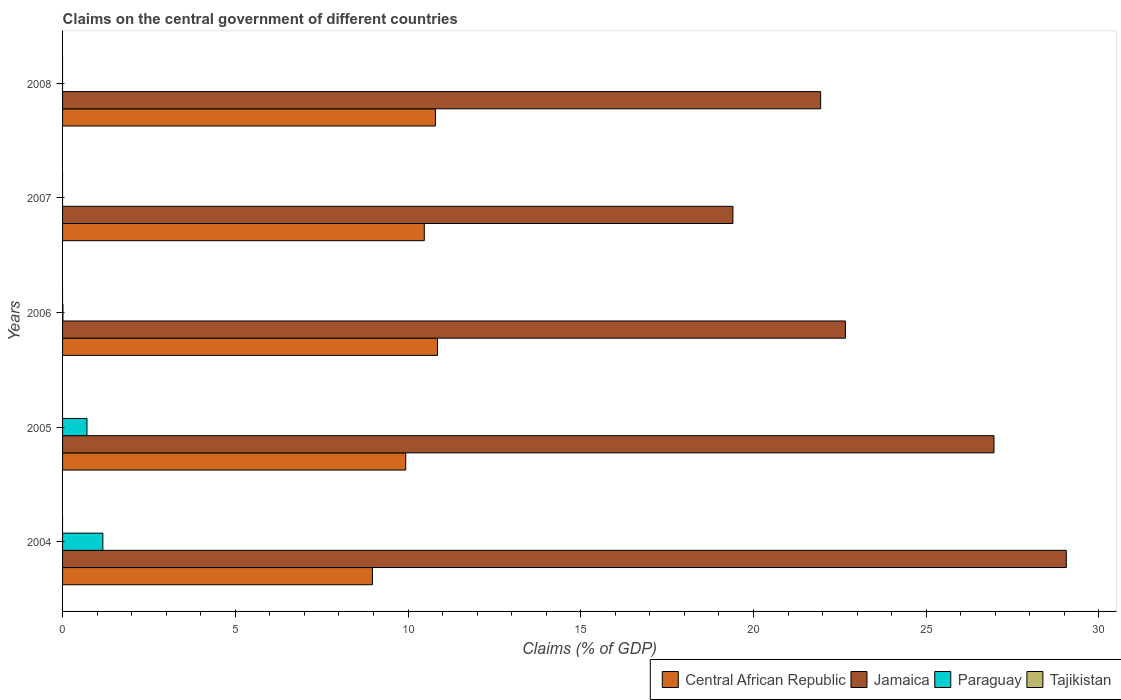How many groups of bars are there?
Your answer should be compact. 5. How many bars are there on the 5th tick from the top?
Your response must be concise. 3. How many bars are there on the 2nd tick from the bottom?
Offer a terse response. 3. What is the label of the 5th group of bars from the top?
Give a very brief answer. 2004. In how many cases, is the number of bars for a given year not equal to the number of legend labels?
Provide a short and direct response. 5. What is the percentage of GDP claimed on the central government in Tajikistan in 2008?
Offer a very short reply. 0. Across all years, what is the maximum percentage of GDP claimed on the central government in Jamaica?
Offer a very short reply. 29.06. Across all years, what is the minimum percentage of GDP claimed on the central government in Tajikistan?
Your response must be concise. 0. In which year was the percentage of GDP claimed on the central government in Central African Republic maximum?
Give a very brief answer. 2006. What is the total percentage of GDP claimed on the central government in Paraguay in the graph?
Your response must be concise. 1.88. What is the difference between the percentage of GDP claimed on the central government in Jamaica in 2004 and that in 2008?
Your answer should be very brief. 7.11. What is the difference between the percentage of GDP claimed on the central government in Tajikistan in 2004 and the percentage of GDP claimed on the central government in Central African Republic in 2005?
Your answer should be very brief. -9.93. In the year 2004, what is the difference between the percentage of GDP claimed on the central government in Paraguay and percentage of GDP claimed on the central government in Central African Republic?
Your answer should be very brief. -7.8. What is the ratio of the percentage of GDP claimed on the central government in Central African Republic in 2006 to that in 2007?
Offer a very short reply. 1.04. Is the percentage of GDP claimed on the central government in Central African Republic in 2004 less than that in 2008?
Ensure brevity in your answer.  Yes. What is the difference between the highest and the second highest percentage of GDP claimed on the central government in Paraguay?
Offer a terse response. 0.46. What is the difference between the highest and the lowest percentage of GDP claimed on the central government in Jamaica?
Provide a short and direct response. 9.65. In how many years, is the percentage of GDP claimed on the central government in Tajikistan greater than the average percentage of GDP claimed on the central government in Tajikistan taken over all years?
Offer a terse response. 0. Is the sum of the percentage of GDP claimed on the central government in Jamaica in 2005 and 2008 greater than the maximum percentage of GDP claimed on the central government in Paraguay across all years?
Your answer should be compact. Yes. Is it the case that in every year, the sum of the percentage of GDP claimed on the central government in Tajikistan and percentage of GDP claimed on the central government in Jamaica is greater than the sum of percentage of GDP claimed on the central government in Central African Republic and percentage of GDP claimed on the central government in Paraguay?
Your answer should be compact. Yes. Is it the case that in every year, the sum of the percentage of GDP claimed on the central government in Paraguay and percentage of GDP claimed on the central government in Central African Republic is greater than the percentage of GDP claimed on the central government in Tajikistan?
Make the answer very short. Yes. Are all the bars in the graph horizontal?
Ensure brevity in your answer.  Yes. Does the graph contain grids?
Ensure brevity in your answer.  No. How many legend labels are there?
Offer a terse response. 4. How are the legend labels stacked?
Offer a terse response. Horizontal. What is the title of the graph?
Offer a terse response. Claims on the central government of different countries. What is the label or title of the X-axis?
Keep it short and to the point. Claims (% of GDP). What is the Claims (% of GDP) in Central African Republic in 2004?
Ensure brevity in your answer.  8.97. What is the Claims (% of GDP) in Jamaica in 2004?
Make the answer very short. 29.06. What is the Claims (% of GDP) in Paraguay in 2004?
Keep it short and to the point. 1.17. What is the Claims (% of GDP) of Tajikistan in 2004?
Your answer should be compact. 0. What is the Claims (% of GDP) of Central African Republic in 2005?
Offer a terse response. 9.93. What is the Claims (% of GDP) of Jamaica in 2005?
Offer a very short reply. 26.96. What is the Claims (% of GDP) in Paraguay in 2005?
Your response must be concise. 0.71. What is the Claims (% of GDP) in Tajikistan in 2005?
Provide a succinct answer. 0. What is the Claims (% of GDP) of Central African Republic in 2006?
Provide a succinct answer. 10.85. What is the Claims (% of GDP) in Jamaica in 2006?
Offer a terse response. 22.66. What is the Claims (% of GDP) of Paraguay in 2006?
Ensure brevity in your answer.  0.01. What is the Claims (% of GDP) of Central African Republic in 2007?
Give a very brief answer. 10.47. What is the Claims (% of GDP) of Jamaica in 2007?
Offer a terse response. 19.41. What is the Claims (% of GDP) of Paraguay in 2007?
Your response must be concise. 0. What is the Claims (% of GDP) in Tajikistan in 2007?
Provide a succinct answer. 0. What is the Claims (% of GDP) in Central African Republic in 2008?
Give a very brief answer. 10.79. What is the Claims (% of GDP) of Jamaica in 2008?
Give a very brief answer. 21.94. What is the Claims (% of GDP) of Paraguay in 2008?
Make the answer very short. 0. Across all years, what is the maximum Claims (% of GDP) of Central African Republic?
Keep it short and to the point. 10.85. Across all years, what is the maximum Claims (% of GDP) of Jamaica?
Offer a very short reply. 29.06. Across all years, what is the maximum Claims (% of GDP) in Paraguay?
Give a very brief answer. 1.17. Across all years, what is the minimum Claims (% of GDP) in Central African Republic?
Offer a very short reply. 8.97. Across all years, what is the minimum Claims (% of GDP) of Jamaica?
Provide a succinct answer. 19.41. What is the total Claims (% of GDP) of Central African Republic in the graph?
Make the answer very short. 51.02. What is the total Claims (% of GDP) in Jamaica in the graph?
Ensure brevity in your answer.  120.03. What is the total Claims (% of GDP) in Paraguay in the graph?
Make the answer very short. 1.88. What is the difference between the Claims (% of GDP) in Central African Republic in 2004 and that in 2005?
Your answer should be very brief. -0.96. What is the difference between the Claims (% of GDP) in Jamaica in 2004 and that in 2005?
Your response must be concise. 2.09. What is the difference between the Claims (% of GDP) in Paraguay in 2004 and that in 2005?
Provide a succinct answer. 0.46. What is the difference between the Claims (% of GDP) in Central African Republic in 2004 and that in 2006?
Your answer should be very brief. -1.88. What is the difference between the Claims (% of GDP) of Jamaica in 2004 and that in 2006?
Offer a terse response. 6.4. What is the difference between the Claims (% of GDP) of Paraguay in 2004 and that in 2006?
Your response must be concise. 1.16. What is the difference between the Claims (% of GDP) in Central African Republic in 2004 and that in 2007?
Make the answer very short. -1.5. What is the difference between the Claims (% of GDP) of Jamaica in 2004 and that in 2007?
Offer a terse response. 9.65. What is the difference between the Claims (% of GDP) in Central African Republic in 2004 and that in 2008?
Your response must be concise. -1.82. What is the difference between the Claims (% of GDP) in Jamaica in 2004 and that in 2008?
Your response must be concise. 7.11. What is the difference between the Claims (% of GDP) of Central African Republic in 2005 and that in 2006?
Your response must be concise. -0.92. What is the difference between the Claims (% of GDP) in Jamaica in 2005 and that in 2006?
Keep it short and to the point. 4.3. What is the difference between the Claims (% of GDP) of Paraguay in 2005 and that in 2006?
Offer a terse response. 0.7. What is the difference between the Claims (% of GDP) in Central African Republic in 2005 and that in 2007?
Your answer should be compact. -0.54. What is the difference between the Claims (% of GDP) in Jamaica in 2005 and that in 2007?
Your answer should be very brief. 7.56. What is the difference between the Claims (% of GDP) in Central African Republic in 2005 and that in 2008?
Keep it short and to the point. -0.86. What is the difference between the Claims (% of GDP) in Jamaica in 2005 and that in 2008?
Make the answer very short. 5.02. What is the difference between the Claims (% of GDP) of Central African Republic in 2006 and that in 2007?
Make the answer very short. 0.38. What is the difference between the Claims (% of GDP) of Jamaica in 2006 and that in 2007?
Give a very brief answer. 3.26. What is the difference between the Claims (% of GDP) of Central African Republic in 2006 and that in 2008?
Make the answer very short. 0.06. What is the difference between the Claims (% of GDP) in Jamaica in 2006 and that in 2008?
Give a very brief answer. 0.72. What is the difference between the Claims (% of GDP) of Central African Republic in 2007 and that in 2008?
Provide a short and direct response. -0.32. What is the difference between the Claims (% of GDP) of Jamaica in 2007 and that in 2008?
Provide a succinct answer. -2.54. What is the difference between the Claims (% of GDP) of Central African Republic in 2004 and the Claims (% of GDP) of Jamaica in 2005?
Give a very brief answer. -17.99. What is the difference between the Claims (% of GDP) in Central African Republic in 2004 and the Claims (% of GDP) in Paraguay in 2005?
Offer a very short reply. 8.26. What is the difference between the Claims (% of GDP) in Jamaica in 2004 and the Claims (% of GDP) in Paraguay in 2005?
Offer a terse response. 28.35. What is the difference between the Claims (% of GDP) in Central African Republic in 2004 and the Claims (% of GDP) in Jamaica in 2006?
Make the answer very short. -13.69. What is the difference between the Claims (% of GDP) in Central African Republic in 2004 and the Claims (% of GDP) in Paraguay in 2006?
Offer a very short reply. 8.96. What is the difference between the Claims (% of GDP) in Jamaica in 2004 and the Claims (% of GDP) in Paraguay in 2006?
Keep it short and to the point. 29.05. What is the difference between the Claims (% of GDP) in Central African Republic in 2004 and the Claims (% of GDP) in Jamaica in 2007?
Ensure brevity in your answer.  -10.43. What is the difference between the Claims (% of GDP) in Central African Republic in 2004 and the Claims (% of GDP) in Jamaica in 2008?
Make the answer very short. -12.97. What is the difference between the Claims (% of GDP) in Central African Republic in 2005 and the Claims (% of GDP) in Jamaica in 2006?
Your answer should be compact. -12.73. What is the difference between the Claims (% of GDP) in Central African Republic in 2005 and the Claims (% of GDP) in Paraguay in 2006?
Your response must be concise. 9.92. What is the difference between the Claims (% of GDP) of Jamaica in 2005 and the Claims (% of GDP) of Paraguay in 2006?
Offer a very short reply. 26.95. What is the difference between the Claims (% of GDP) of Central African Republic in 2005 and the Claims (% of GDP) of Jamaica in 2007?
Your answer should be compact. -9.47. What is the difference between the Claims (% of GDP) in Central African Republic in 2005 and the Claims (% of GDP) in Jamaica in 2008?
Your answer should be compact. -12.01. What is the difference between the Claims (% of GDP) in Central African Republic in 2006 and the Claims (% of GDP) in Jamaica in 2007?
Give a very brief answer. -8.55. What is the difference between the Claims (% of GDP) in Central African Republic in 2006 and the Claims (% of GDP) in Jamaica in 2008?
Your answer should be compact. -11.09. What is the difference between the Claims (% of GDP) in Central African Republic in 2007 and the Claims (% of GDP) in Jamaica in 2008?
Give a very brief answer. -11.47. What is the average Claims (% of GDP) of Central African Republic per year?
Ensure brevity in your answer.  10.2. What is the average Claims (% of GDP) in Jamaica per year?
Offer a very short reply. 24.01. What is the average Claims (% of GDP) of Paraguay per year?
Make the answer very short. 0.38. In the year 2004, what is the difference between the Claims (% of GDP) in Central African Republic and Claims (% of GDP) in Jamaica?
Offer a very short reply. -20.09. In the year 2004, what is the difference between the Claims (% of GDP) of Central African Republic and Claims (% of GDP) of Paraguay?
Provide a succinct answer. 7.8. In the year 2004, what is the difference between the Claims (% of GDP) of Jamaica and Claims (% of GDP) of Paraguay?
Your answer should be compact. 27.89. In the year 2005, what is the difference between the Claims (% of GDP) of Central African Republic and Claims (% of GDP) of Jamaica?
Keep it short and to the point. -17.03. In the year 2005, what is the difference between the Claims (% of GDP) of Central African Republic and Claims (% of GDP) of Paraguay?
Ensure brevity in your answer.  9.23. In the year 2005, what is the difference between the Claims (% of GDP) in Jamaica and Claims (% of GDP) in Paraguay?
Ensure brevity in your answer.  26.26. In the year 2006, what is the difference between the Claims (% of GDP) in Central African Republic and Claims (% of GDP) in Jamaica?
Offer a terse response. -11.81. In the year 2006, what is the difference between the Claims (% of GDP) of Central African Republic and Claims (% of GDP) of Paraguay?
Give a very brief answer. 10.84. In the year 2006, what is the difference between the Claims (% of GDP) in Jamaica and Claims (% of GDP) in Paraguay?
Give a very brief answer. 22.65. In the year 2007, what is the difference between the Claims (% of GDP) of Central African Republic and Claims (% of GDP) of Jamaica?
Offer a very short reply. -8.93. In the year 2008, what is the difference between the Claims (% of GDP) in Central African Republic and Claims (% of GDP) in Jamaica?
Make the answer very short. -11.15. What is the ratio of the Claims (% of GDP) in Central African Republic in 2004 to that in 2005?
Your answer should be compact. 0.9. What is the ratio of the Claims (% of GDP) of Jamaica in 2004 to that in 2005?
Provide a succinct answer. 1.08. What is the ratio of the Claims (% of GDP) of Paraguay in 2004 to that in 2005?
Keep it short and to the point. 1.65. What is the ratio of the Claims (% of GDP) of Central African Republic in 2004 to that in 2006?
Offer a very short reply. 0.83. What is the ratio of the Claims (% of GDP) in Jamaica in 2004 to that in 2006?
Keep it short and to the point. 1.28. What is the ratio of the Claims (% of GDP) of Paraguay in 2004 to that in 2006?
Keep it short and to the point. 109.2. What is the ratio of the Claims (% of GDP) in Central African Republic in 2004 to that in 2007?
Your answer should be compact. 0.86. What is the ratio of the Claims (% of GDP) of Jamaica in 2004 to that in 2007?
Keep it short and to the point. 1.5. What is the ratio of the Claims (% of GDP) in Central African Republic in 2004 to that in 2008?
Provide a short and direct response. 0.83. What is the ratio of the Claims (% of GDP) of Jamaica in 2004 to that in 2008?
Offer a terse response. 1.32. What is the ratio of the Claims (% of GDP) of Central African Republic in 2005 to that in 2006?
Ensure brevity in your answer.  0.92. What is the ratio of the Claims (% of GDP) in Jamaica in 2005 to that in 2006?
Provide a short and direct response. 1.19. What is the ratio of the Claims (% of GDP) in Paraguay in 2005 to that in 2006?
Your response must be concise. 66.2. What is the ratio of the Claims (% of GDP) in Central African Republic in 2005 to that in 2007?
Keep it short and to the point. 0.95. What is the ratio of the Claims (% of GDP) in Jamaica in 2005 to that in 2007?
Your answer should be compact. 1.39. What is the ratio of the Claims (% of GDP) in Central African Republic in 2005 to that in 2008?
Ensure brevity in your answer.  0.92. What is the ratio of the Claims (% of GDP) in Jamaica in 2005 to that in 2008?
Give a very brief answer. 1.23. What is the ratio of the Claims (% of GDP) in Central African Republic in 2006 to that in 2007?
Your answer should be compact. 1.04. What is the ratio of the Claims (% of GDP) in Jamaica in 2006 to that in 2007?
Give a very brief answer. 1.17. What is the ratio of the Claims (% of GDP) in Central African Republic in 2006 to that in 2008?
Give a very brief answer. 1.01. What is the ratio of the Claims (% of GDP) in Jamaica in 2006 to that in 2008?
Offer a very short reply. 1.03. What is the ratio of the Claims (% of GDP) in Central African Republic in 2007 to that in 2008?
Your answer should be compact. 0.97. What is the ratio of the Claims (% of GDP) in Jamaica in 2007 to that in 2008?
Give a very brief answer. 0.88. What is the difference between the highest and the second highest Claims (% of GDP) of Central African Republic?
Provide a succinct answer. 0.06. What is the difference between the highest and the second highest Claims (% of GDP) in Jamaica?
Provide a short and direct response. 2.09. What is the difference between the highest and the second highest Claims (% of GDP) of Paraguay?
Your answer should be very brief. 0.46. What is the difference between the highest and the lowest Claims (% of GDP) of Central African Republic?
Provide a short and direct response. 1.88. What is the difference between the highest and the lowest Claims (% of GDP) in Jamaica?
Your answer should be very brief. 9.65. What is the difference between the highest and the lowest Claims (% of GDP) in Paraguay?
Keep it short and to the point. 1.17. 